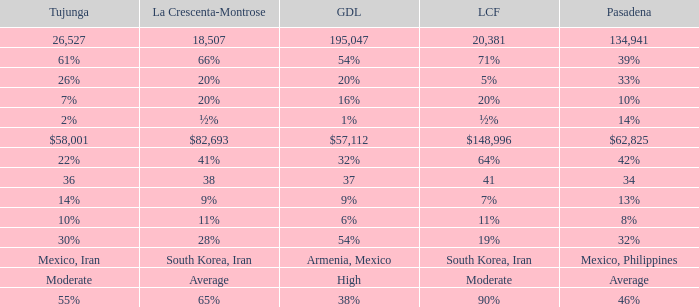When Pasadena is at 10%, what is La Crescenta-Montrose? 20%. 